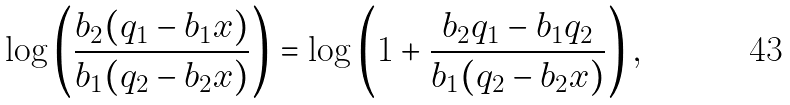Convert formula to latex. <formula><loc_0><loc_0><loc_500><loc_500>\log \left ( \frac { b _ { 2 } ( q _ { 1 } - b _ { 1 } x ) } { b _ { 1 } ( q _ { 2 } - b _ { 2 } x ) } \right ) = \log \left ( 1 + \frac { b _ { 2 } q _ { 1 } - b _ { 1 } q _ { 2 } } { b _ { 1 } ( q _ { 2 } - b _ { 2 } x ) } \right ) ,</formula> 